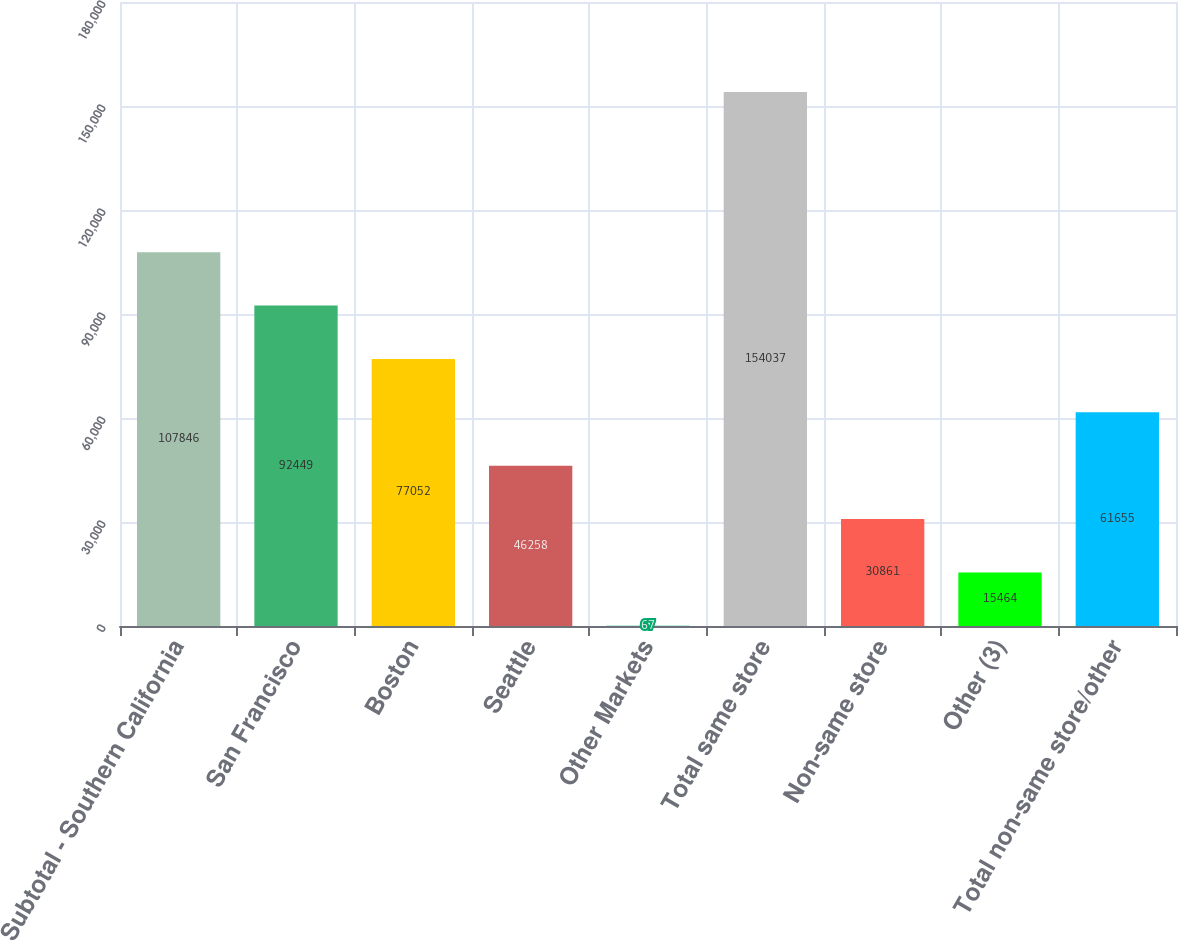Convert chart to OTSL. <chart><loc_0><loc_0><loc_500><loc_500><bar_chart><fcel>Subtotal - Southern California<fcel>San Francisco<fcel>Boston<fcel>Seattle<fcel>Other Markets<fcel>Total same store<fcel>Non-same store<fcel>Other (3)<fcel>Total non-same store/other<nl><fcel>107846<fcel>92449<fcel>77052<fcel>46258<fcel>67<fcel>154037<fcel>30861<fcel>15464<fcel>61655<nl></chart> 